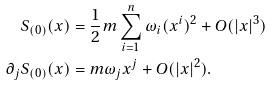Convert formula to latex. <formula><loc_0><loc_0><loc_500><loc_500>S _ { ( 0 ) } ( x ) & = \frac { 1 } { 2 } m \sum _ { i = 1 } ^ { n } \omega _ { i } ( x ^ { i } ) ^ { 2 } + O ( | x | ^ { 3 } ) \\ \partial _ { j } S _ { ( 0 ) } ( x ) & = m \omega _ { j } x ^ { j } + O ( | x | ^ { 2 } ) .</formula> 